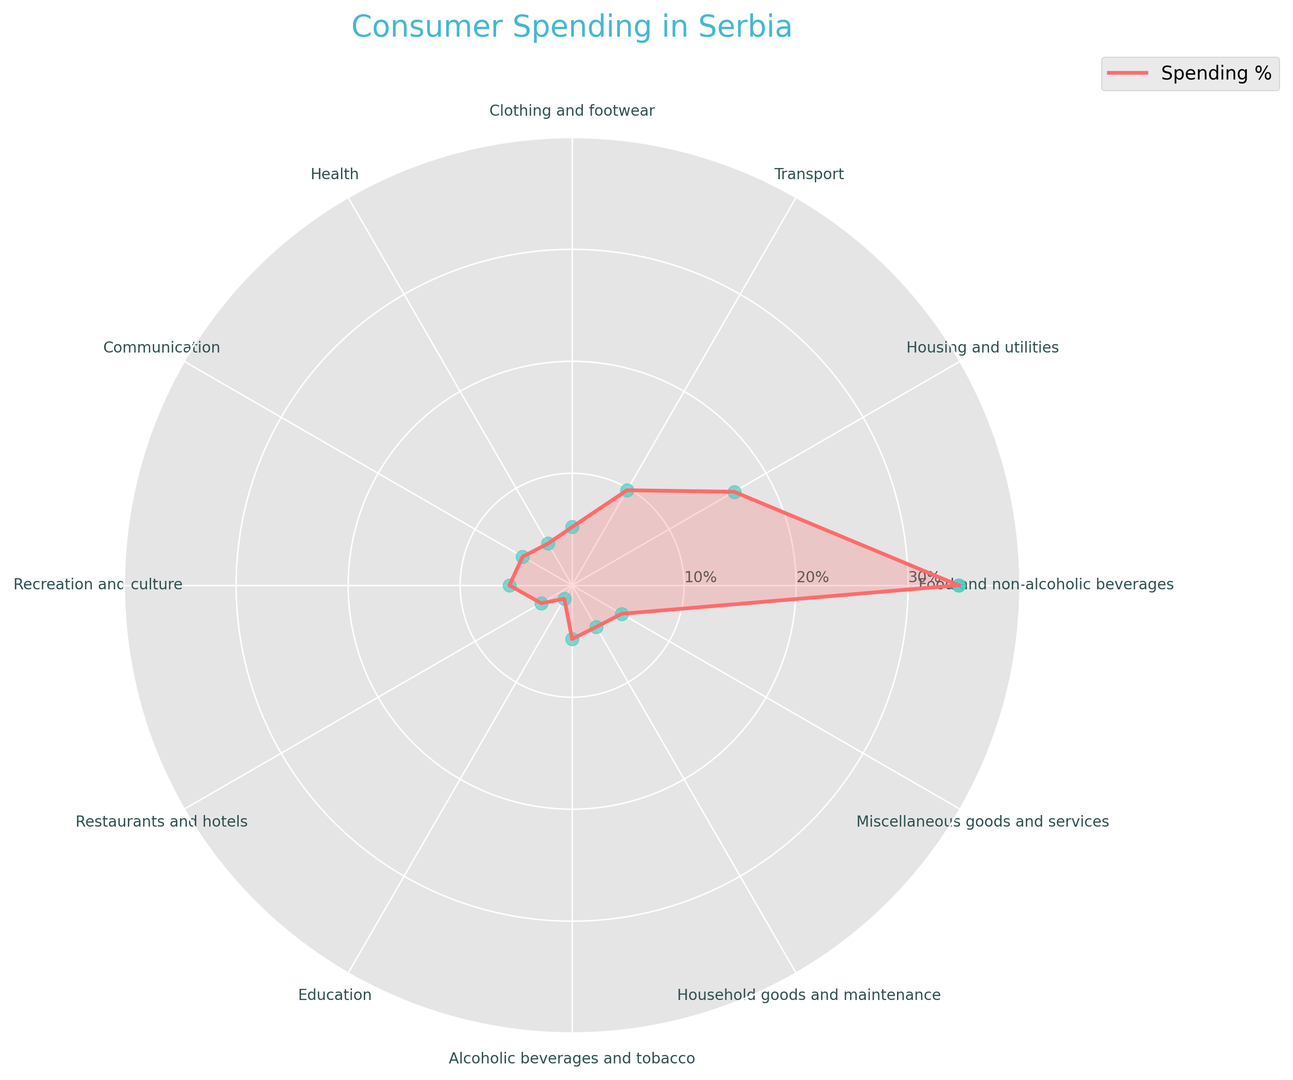What is the percentage of the budget spent on Food and non-alcoholic beverages? The chart shows that the percentage spent on Food and non-alcoholic beverages is clearly labeled around 34.5%.
Answer: 34.5% What category has the highest spending percentage? By observing the chart, the category with the longest radius and largest portion is Food and non-alcoholic beverages, indicating the highest spending percentage.
Answer: Food and non-alcoholic beverages What are the two categories with equal spending percentages? Based on the equal length of the segments in the radar chart, Communication and Miscellaneous goods and services both have the same spending percentages of 5.1%.
Answer: Communication and Miscellaneous goods and services How does spending on Transport compare to spending on Housing and utilities? From a visual standpoint, the segment representing Housing and utilities appears longer than the segment for Transport, suggesting that the spending percentage on Housing and utilities (16.7%) is higher than on Transport (9.8%).
Answer: Housing and utilities is higher than Transport What is the total percentage spent on Restaurants and hotels, Health, and Education combined? Adding up the percentages for Restaurants and hotels (3.2%), Health (4.3%), and Education (1.4%) gives a total of 3.2 + 4.3 + 1.4 = 8.9%.
Answer: 8.9% Is the percentage spent on Alcoholic beverages and tobacco greater or less than the percentage spent on Clothing and footwear? Examining the lengths of the chart's segments, Alcoholic beverages and tobacco at 4.8% is slightly less than Clothing and footwear at 5.2%.
Answer: Less What is the average percentage spent on Health, Communication, and Household goods and maintenance? The average is calculated by summing the three percentages and dividing by 3: (4.3 + 5.1 + 4.3) / 3 = 13.7 / 3 = 4.57%.
Answer: 4.57% Which category has the smallest spending percentage, and what is that percentage? The shortest segment on the radar chart is Education, showing the smallest spending percentage of 1.4%.
Answer: Education, 1.4% What is the percentage difference between spending on Housing and utilities and Miscellaneous goods and services? Subtracting the percentage for Miscellaneous goods and services (5.1%) from Housing and utilities (16.7%) gives a difference of 16.7 - 5.1 = 11.6%.
Answer: 11.6% 